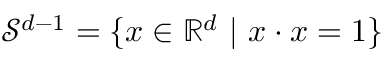<formula> <loc_0><loc_0><loc_500><loc_500>{ \mathcal { S } } ^ { d - 1 } = \{ { x } \in \mathbb { R } ^ { d } | { x } \cdot { x } = 1 \}</formula> 